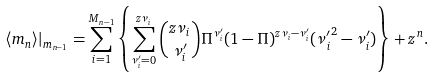<formula> <loc_0><loc_0><loc_500><loc_500>\langle m _ { n } \rangle | _ { m _ { n - 1 } } = \sum _ { i = 1 } ^ { M _ { n - 1 } } \left \{ \sum _ { \nu _ { i } ^ { \prime } = 0 } ^ { z \nu _ { i } } { z \nu _ { i } \choose \nu _ { i } ^ { \prime } } \Pi ^ { \nu _ { i } ^ { \prime } } ( 1 - \Pi ) ^ { z \nu _ { i } - \nu _ { i } ^ { \prime } } ( { \nu _ { i } ^ { \prime } } ^ { 2 } - \nu _ { i } ^ { \prime } ) \right \} + z ^ { n } .</formula> 